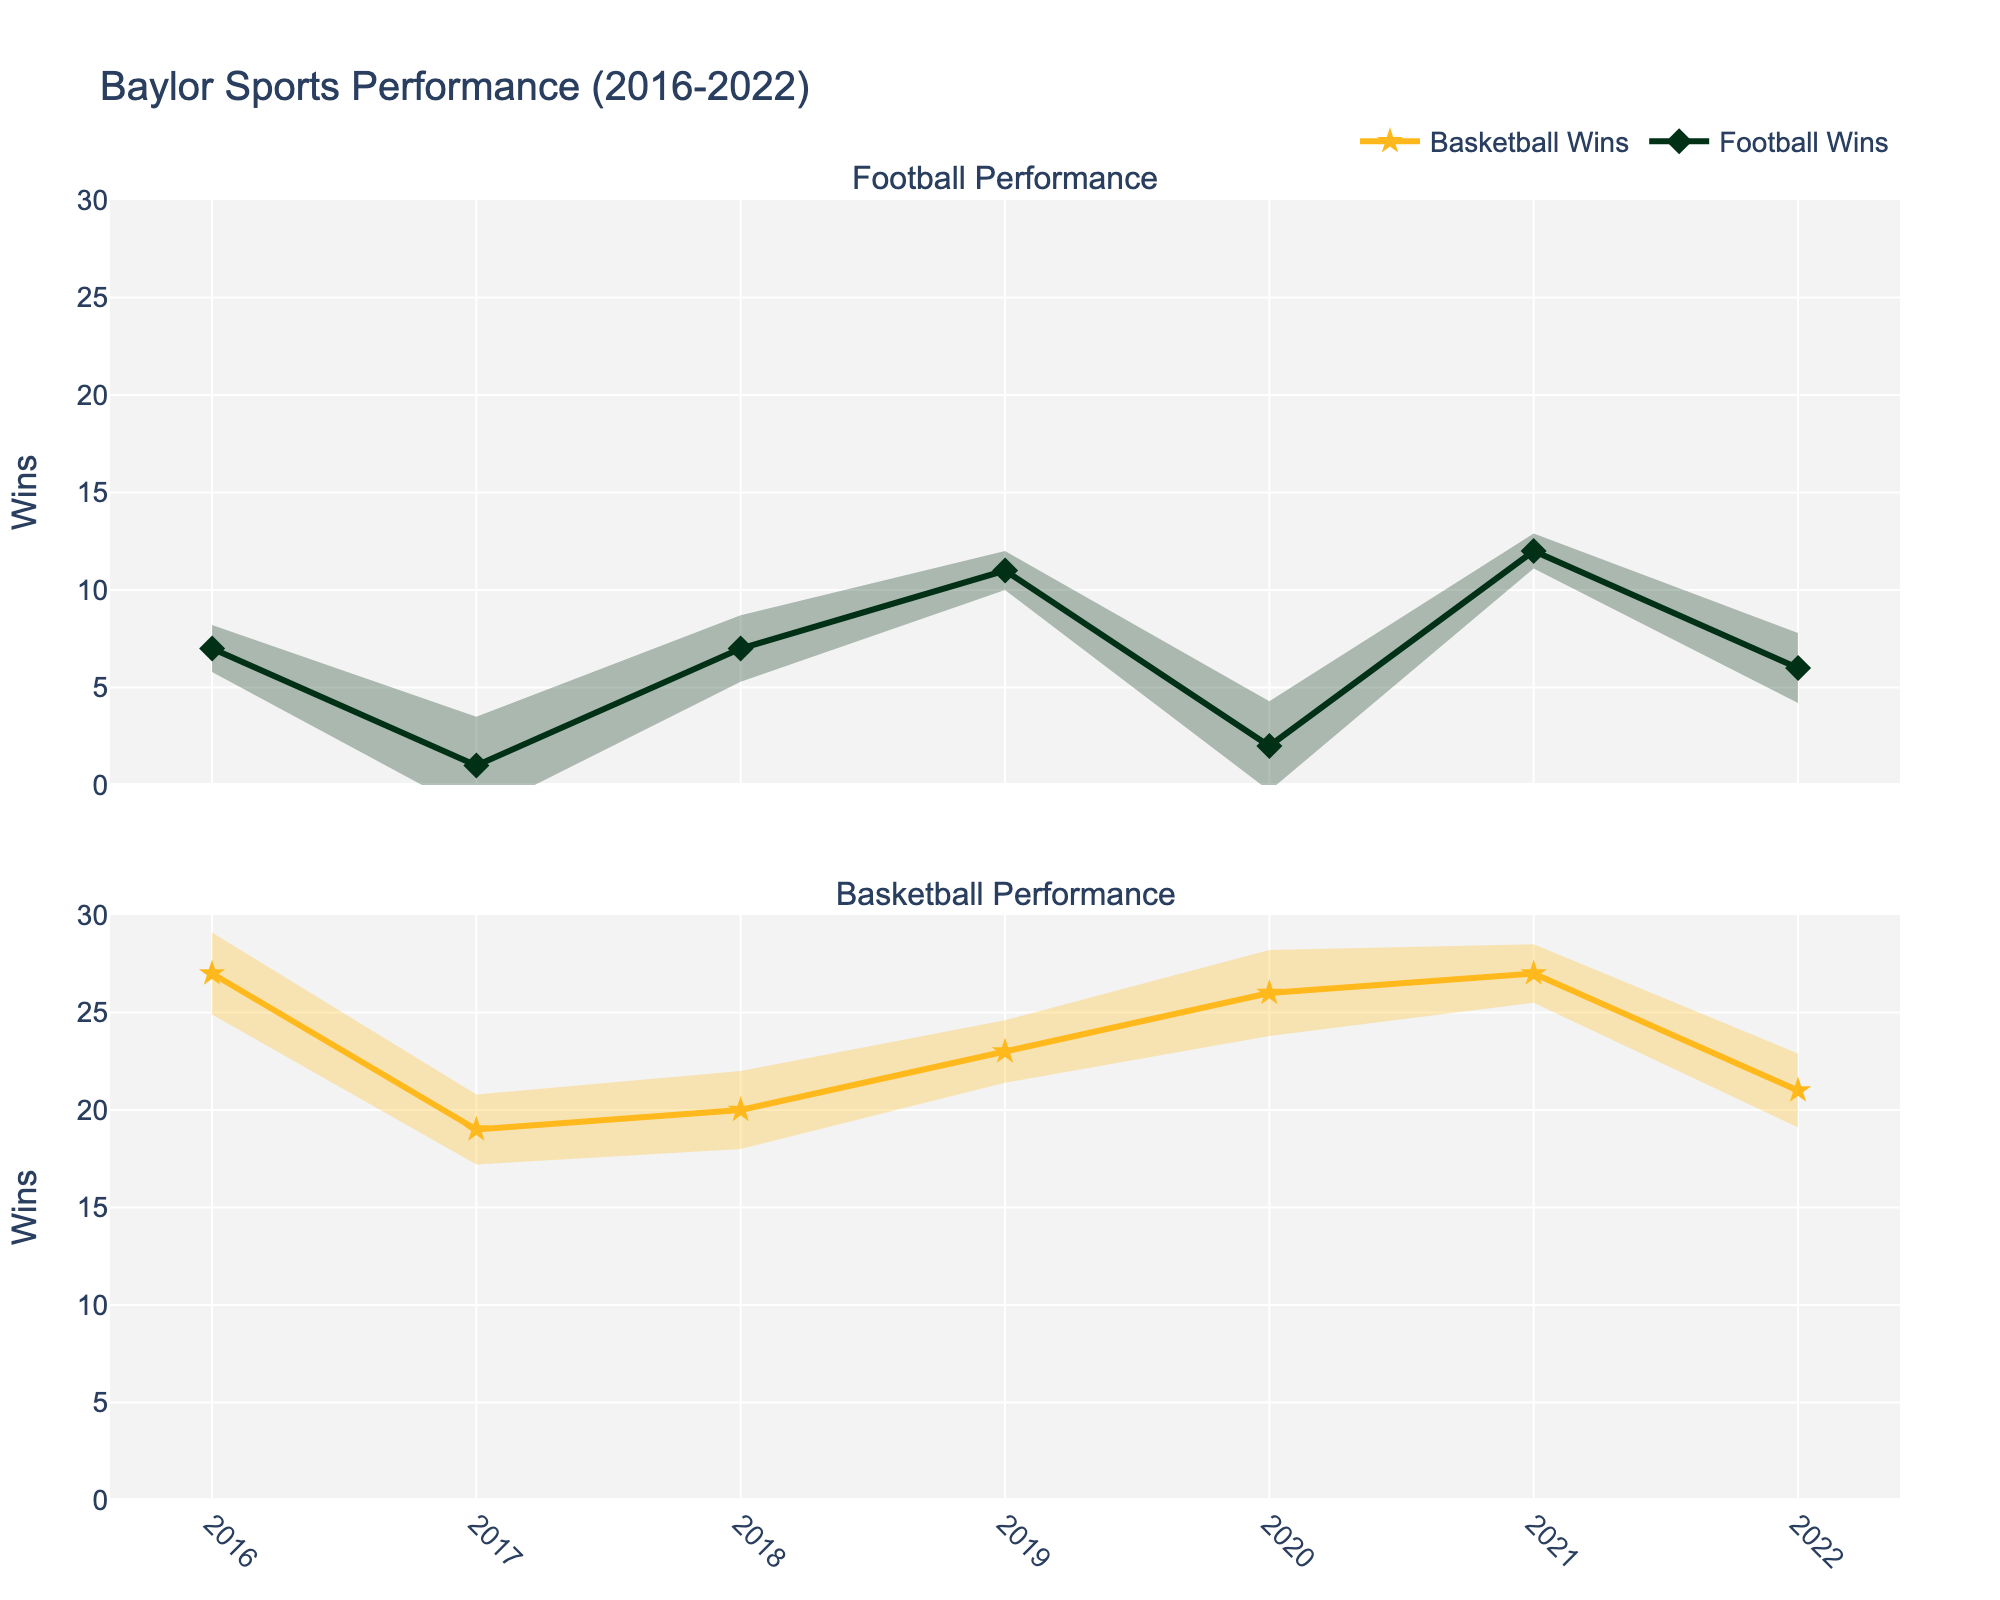What's the title of the figure? The title of the figure is displayed prominently at the top of the plot.
Answer: Baylor Sports Performance (2016-2022) How many years of data does the figure cover for both football and basketball? The x-axis shows data from 2016 to 2022, inclusive. Counting all years gives a total.
Answer: 7 years In which year did the football team achieve the highest number of wins? The line plot for football wins shows the highest peak in 2021.
Answer: 2021 What was the basketball team's performance in terms of wins in 2020? The line plot for basketball shows a clear data point for 2020, marked by a star symbol, indicating 26 wins.
Answer: 26 wins Which year shows the largest discrepancy between football wins and basketball wins? Comparing the heights of the lines for both sports over different years, 2017 shows a significant difference. Football had 1 win and basketball had 19 wins, creating the largest discrepancy.
Answer: 2017 Between 2018 and 2019, did the football team's performance improve or decline? Observing the line plot for football, the wins increased from 7 in 2018 to 11 in 2019, indicating an improvement.
Answer: Improved For which year does the basketball team have the smallest error margin? By comparing the error margins shown as shaded areas above and below each data point, 2021 for basketball seems to have the smallest error margin of 1.5.
Answer: 2021 How many times did the basketball team win more than 25 games? Observing the basketball wins line plot where it reaches above 25 wins, this occurs in 2016, 2020, and 2021.
Answer: 3 times In which year do both football and basketball teams have more losses than wins? Observing the peaks and troughs in both plots, 2017 is the only year where football has 1 win and 11 losses, and basketball has 19 wins and 15 losses. Losses exceed wins for football, and losses are fewer but close for basketball.
Answer: 2017 In 2022, what is the win-loss ratio for the football team? The plot shows the football team won 6 games and lost 7 games in 2022. The win-loss ratio is calculated as wins divided by losses, hence 6/7.
Answer: 0.86 